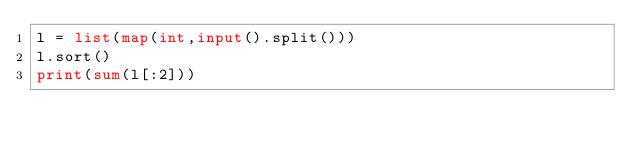Convert code to text. <code><loc_0><loc_0><loc_500><loc_500><_Python_>l = list(map(int,input().split()))
l.sort()
print(sum(l[:2]))</code> 